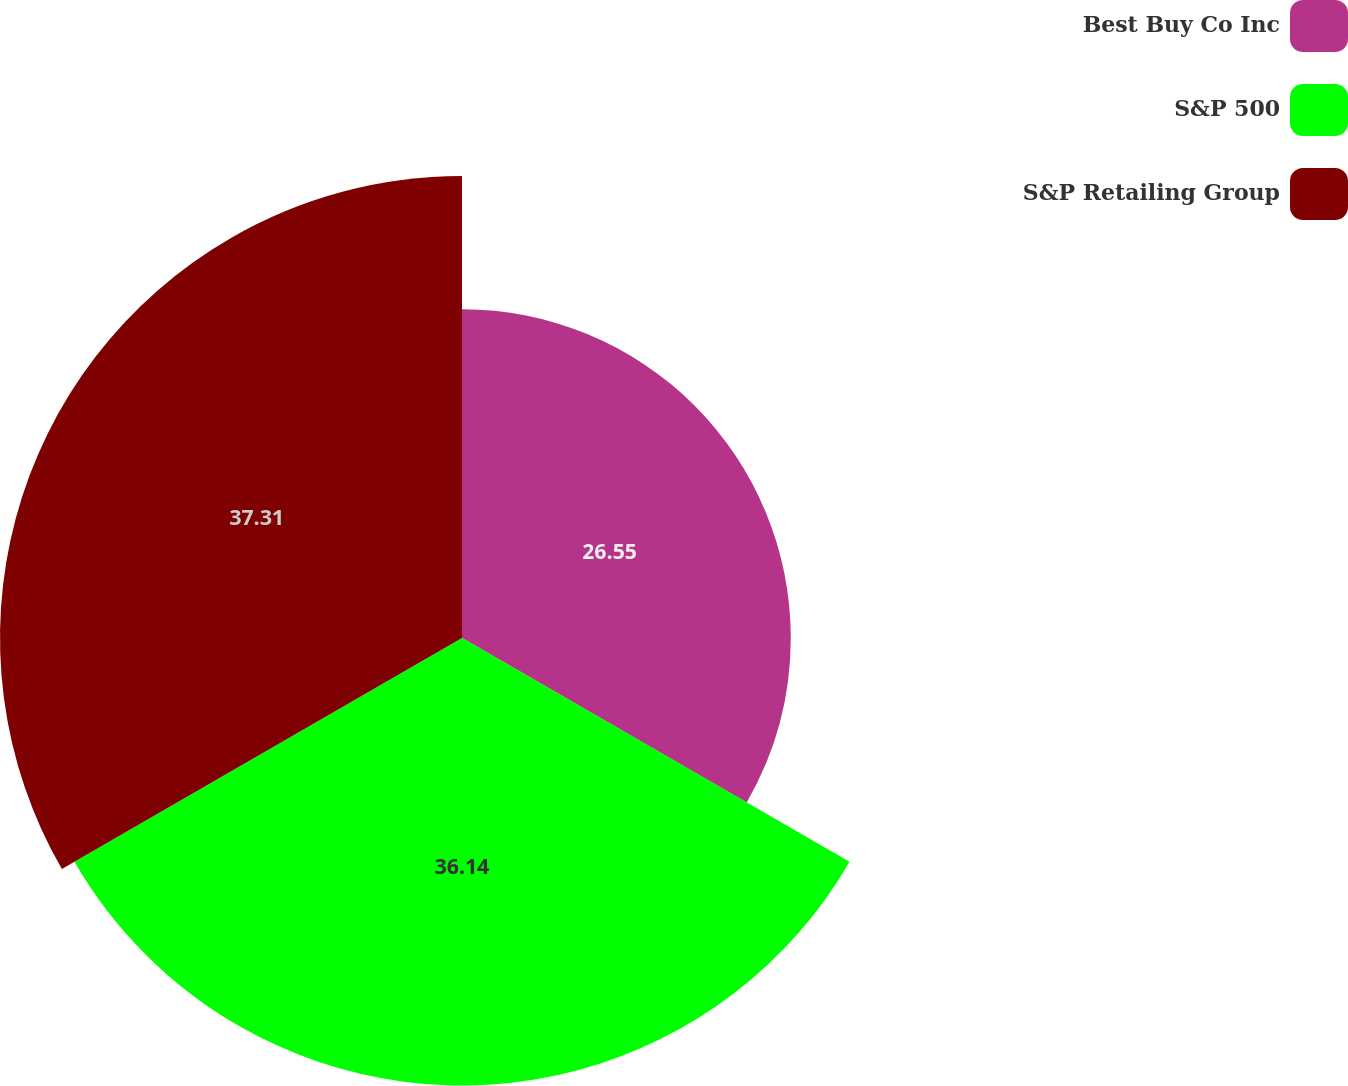Convert chart. <chart><loc_0><loc_0><loc_500><loc_500><pie_chart><fcel>Best Buy Co Inc<fcel>S&P 500<fcel>S&P Retailing Group<nl><fcel>26.55%<fcel>36.14%<fcel>37.31%<nl></chart> 